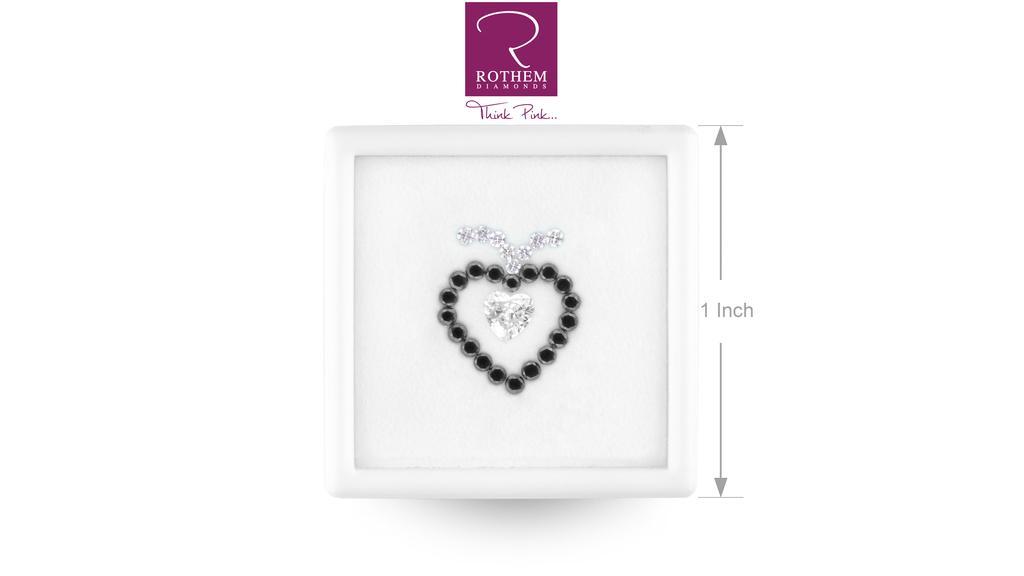In one or two sentences, can you explain what this image depicts? In the middle of the picture, we see a heart shaped symbol is in black color. This might be a photo frame. Beside that, we see text written as "1 inch". In the background, it is white in color. At the top, it is in pink color and we see some text written on it. 